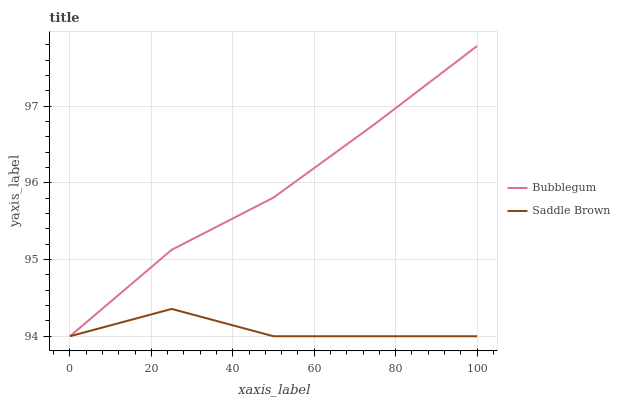Does Saddle Brown have the minimum area under the curve?
Answer yes or no. Yes. Does Bubblegum have the maximum area under the curve?
Answer yes or no. Yes. Does Bubblegum have the minimum area under the curve?
Answer yes or no. No. Is Bubblegum the smoothest?
Answer yes or no. Yes. Is Saddle Brown the roughest?
Answer yes or no. Yes. Is Bubblegum the roughest?
Answer yes or no. No. 